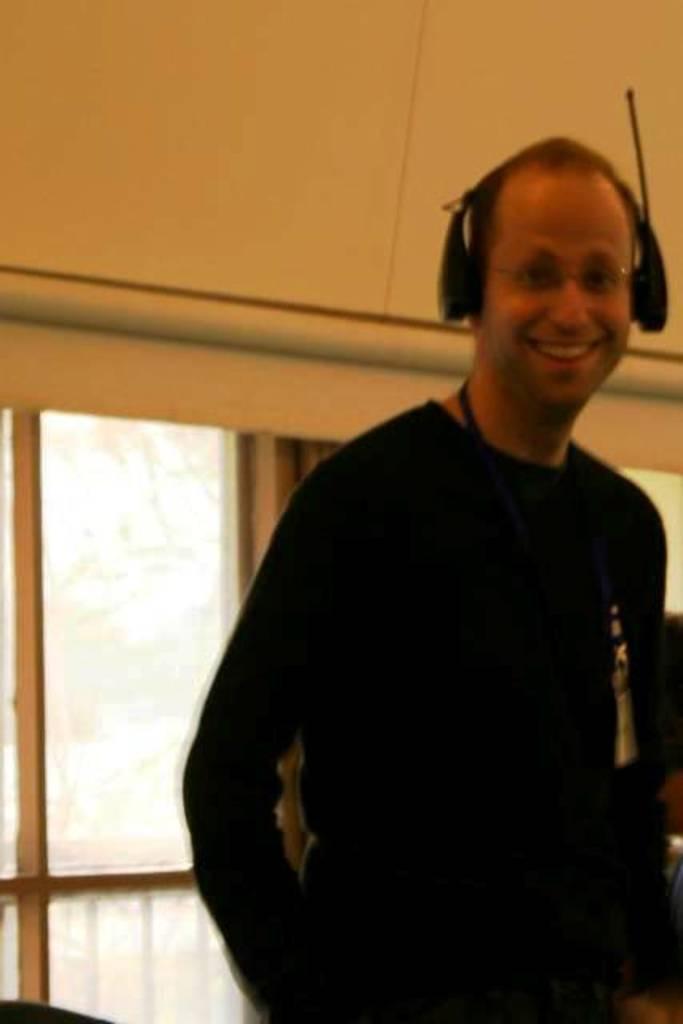Describe this image in one or two sentences. In this image in the foreground there is one person who is standing and smiling, and he is wearing a headset. In the background there is a window, curtains, wall and some other objects. 